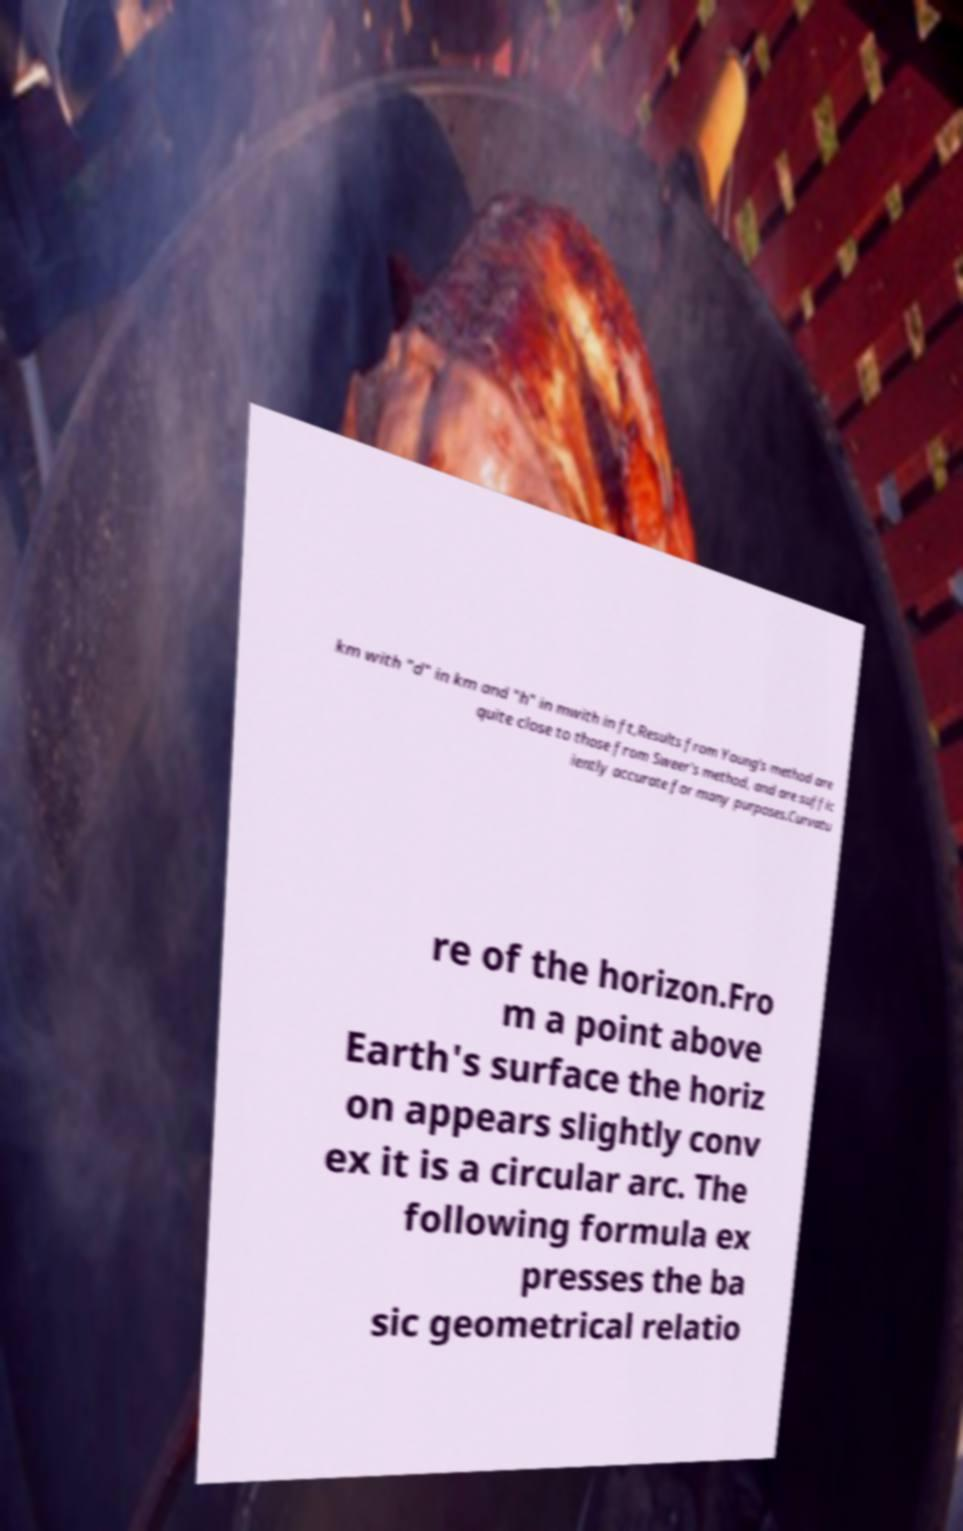I need the written content from this picture converted into text. Can you do that? km with "d" in km and "h" in mwith in ft,Results from Young's method are quite close to those from Sweer's method, and are suffic iently accurate for many purposes.Curvatu re of the horizon.Fro m a point above Earth's surface the horiz on appears slightly conv ex it is a circular arc. The following formula ex presses the ba sic geometrical relatio 